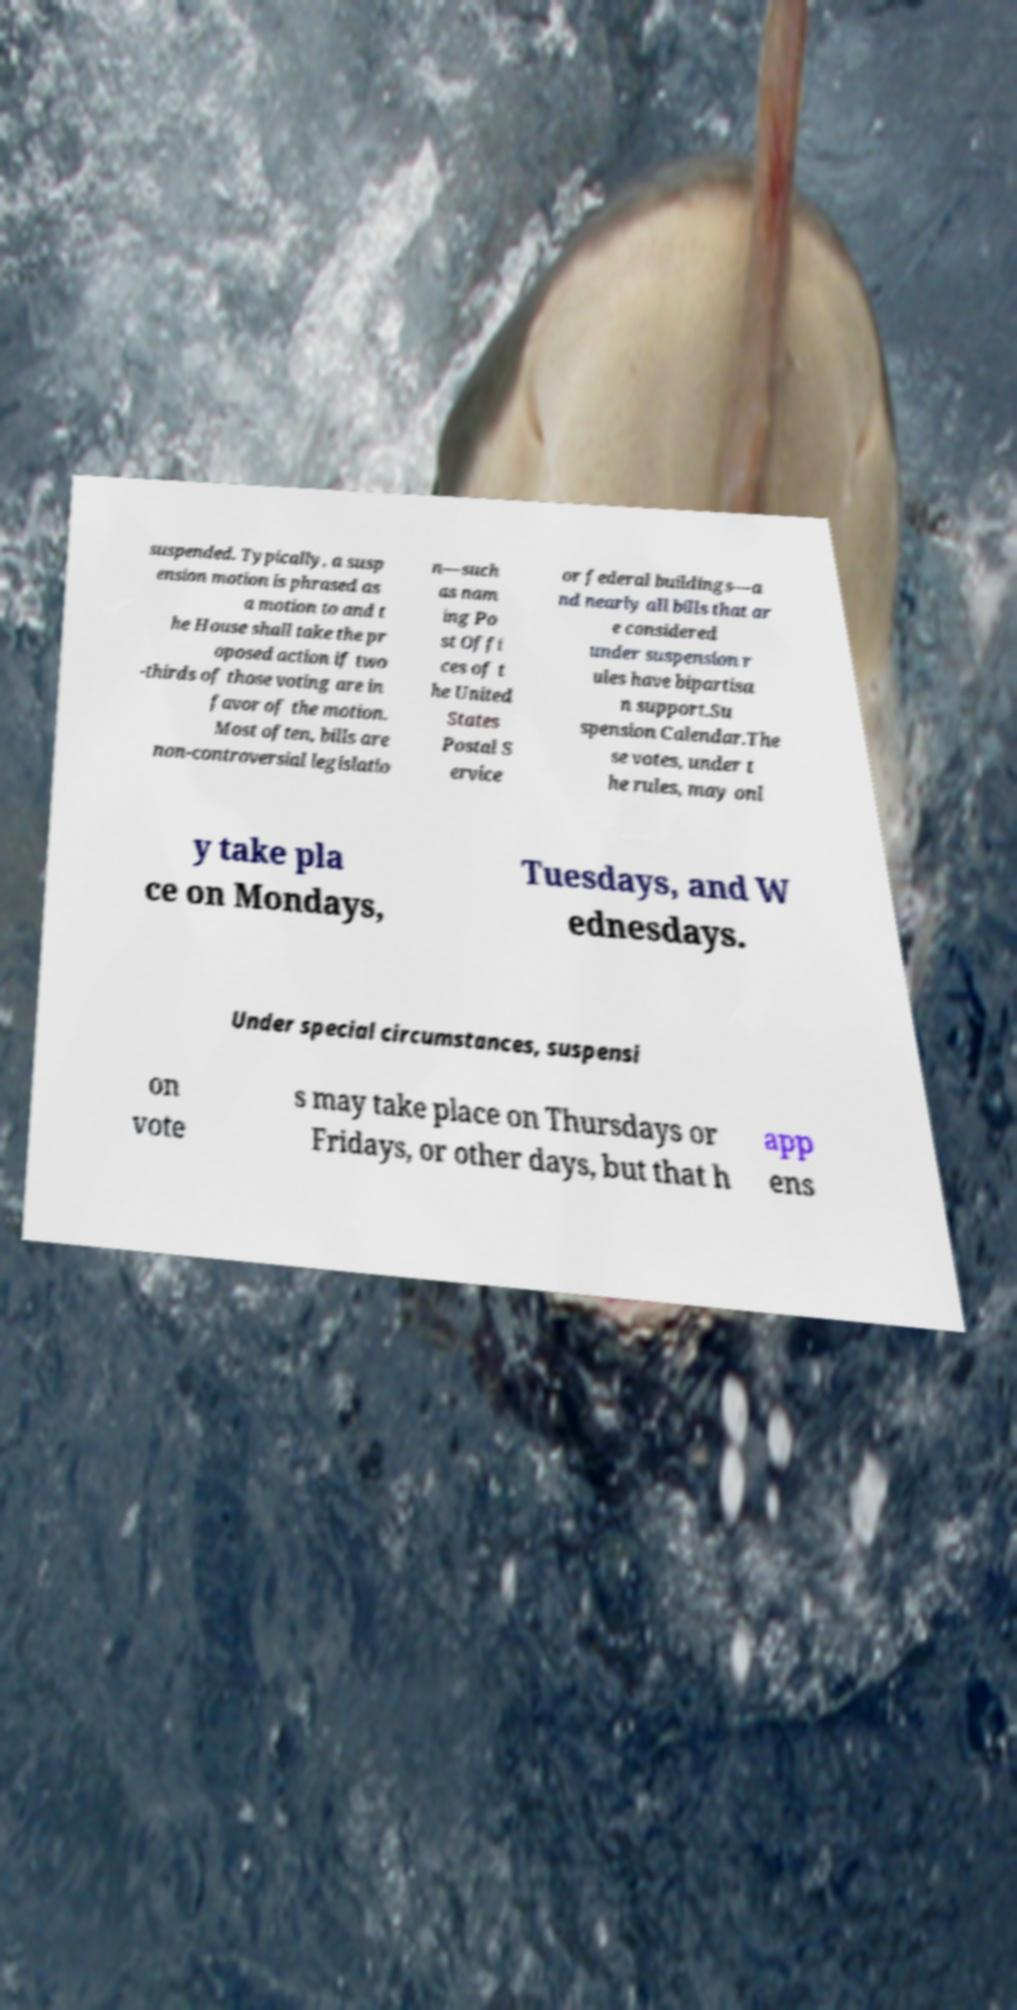There's text embedded in this image that I need extracted. Can you transcribe it verbatim? suspended. Typically, a susp ension motion is phrased as a motion to and t he House shall take the pr oposed action if two -thirds of those voting are in favor of the motion. Most often, bills are non-controversial legislatio n—such as nam ing Po st Offi ces of t he United States Postal S ervice or federal buildings—a nd nearly all bills that ar e considered under suspension r ules have bipartisa n support.Su spension Calendar.The se votes, under t he rules, may onl y take pla ce on Mondays, Tuesdays, and W ednesdays. Under special circumstances, suspensi on vote s may take place on Thursdays or Fridays, or other days, but that h app ens 